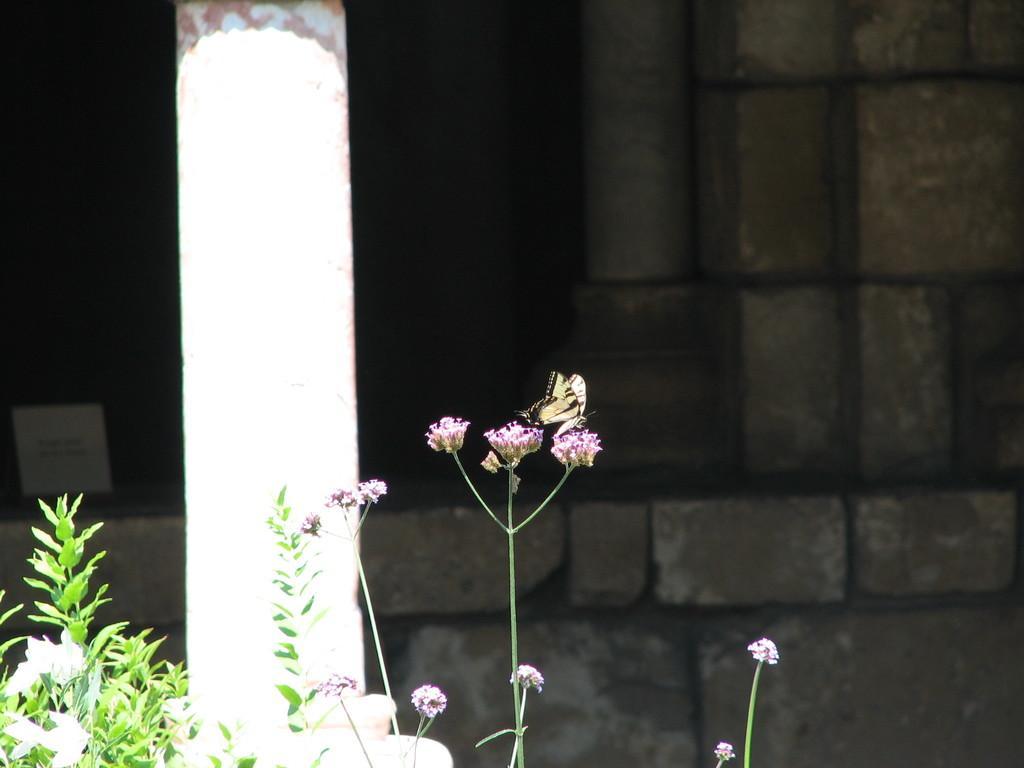Please provide a concise description of this image. In this image I can see a butterfly which is yellow and black in color on a flower which is pink in color. I can see few plants which are green in color, a white colored pillar, a building which is made of bricks and the dark background. 